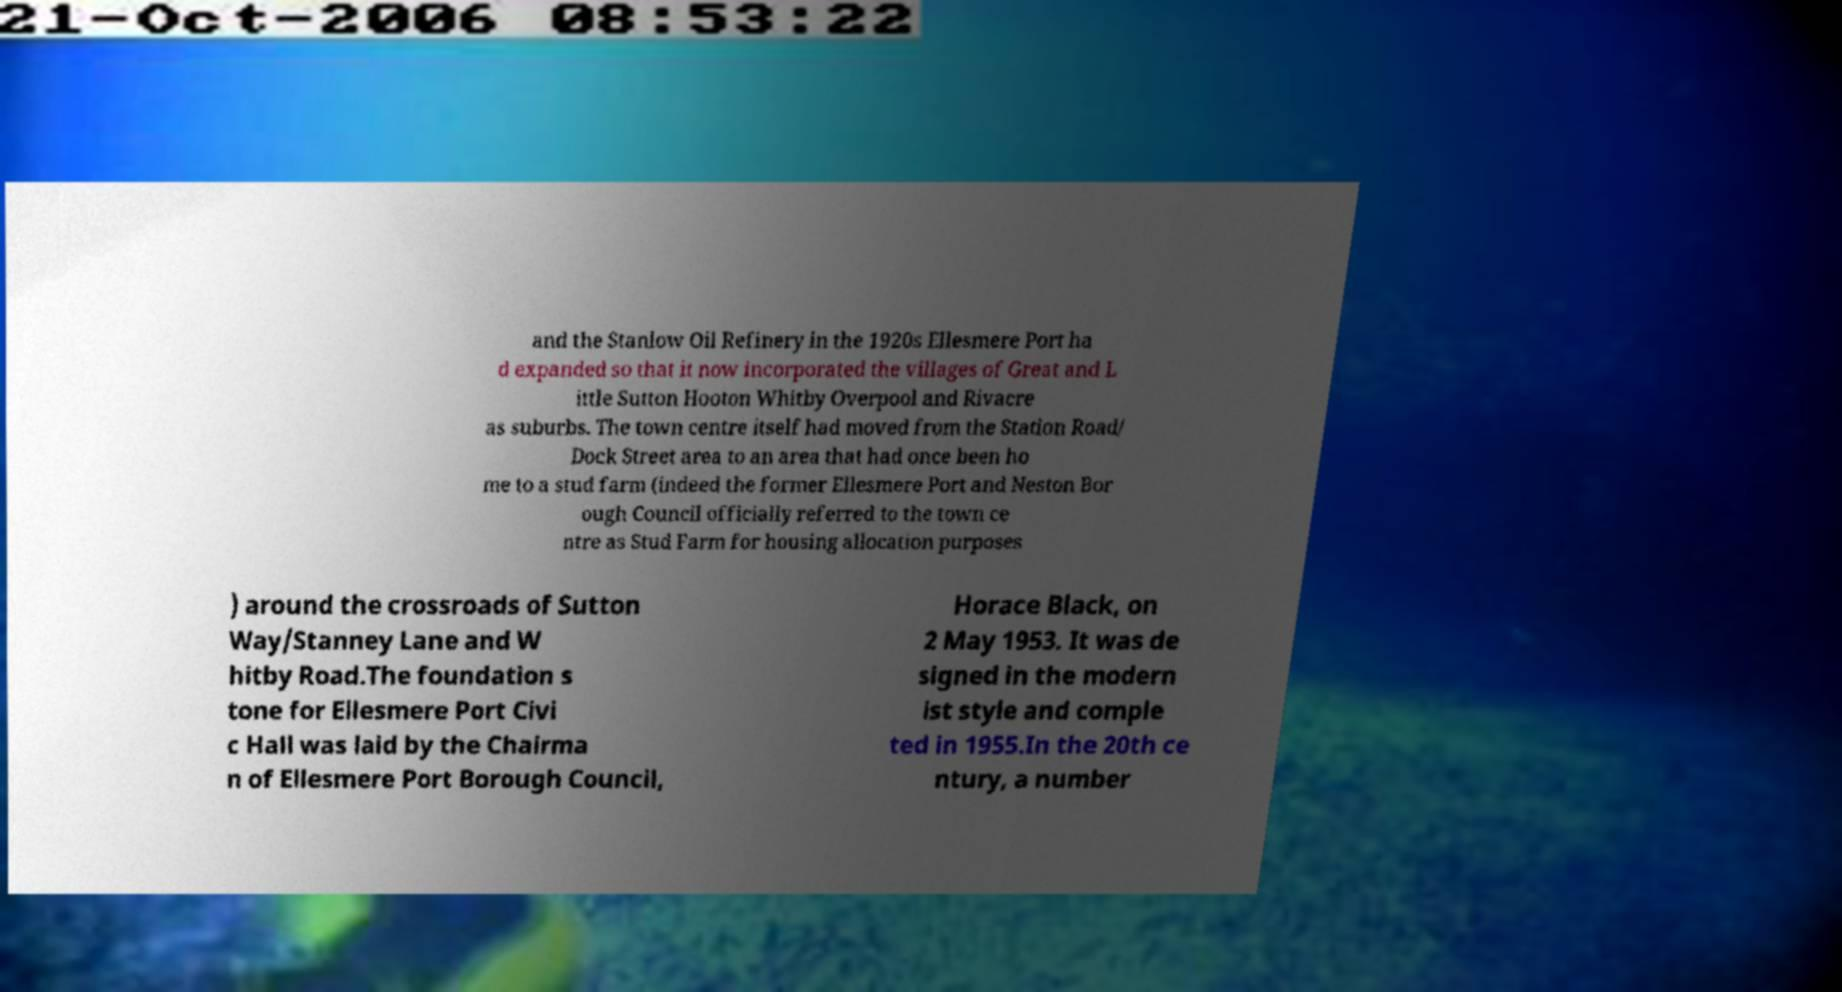Can you read and provide the text displayed in the image?This photo seems to have some interesting text. Can you extract and type it out for me? and the Stanlow Oil Refinery in the 1920s Ellesmere Port ha d expanded so that it now incorporated the villages of Great and L ittle Sutton Hooton Whitby Overpool and Rivacre as suburbs. The town centre itself had moved from the Station Road/ Dock Street area to an area that had once been ho me to a stud farm (indeed the former Ellesmere Port and Neston Bor ough Council officially referred to the town ce ntre as Stud Farm for housing allocation purposes ) around the crossroads of Sutton Way/Stanney Lane and W hitby Road.The foundation s tone for Ellesmere Port Civi c Hall was laid by the Chairma n of Ellesmere Port Borough Council, Horace Black, on 2 May 1953. It was de signed in the modern ist style and comple ted in 1955.In the 20th ce ntury, a number 